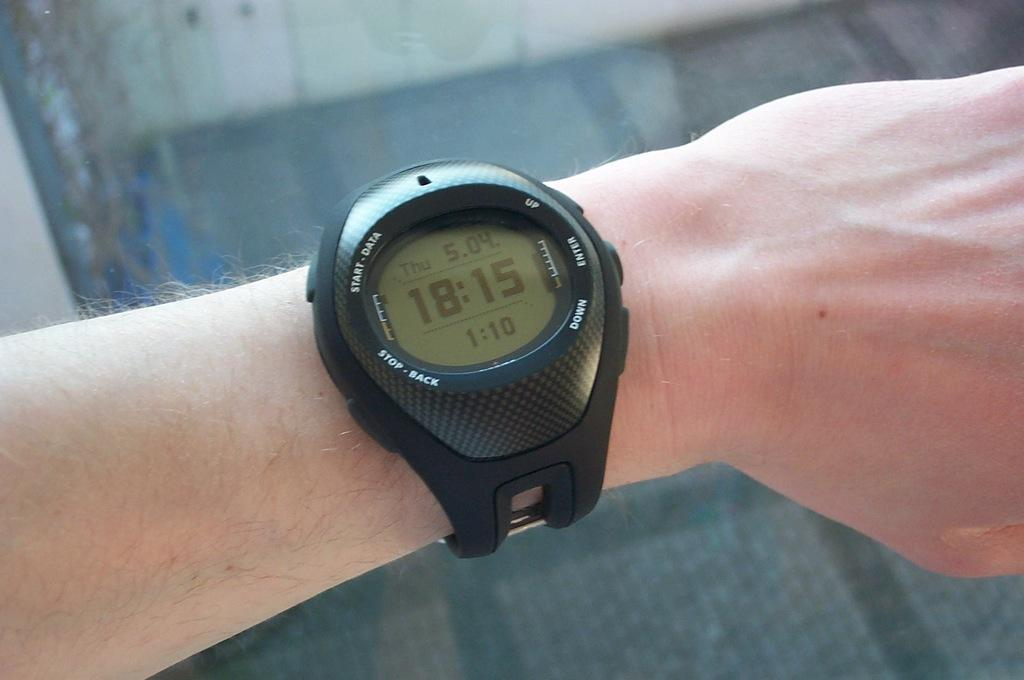<image>
Provide a brief description of the given image. The watch on the person's left wrist displays a time of 18:15. 